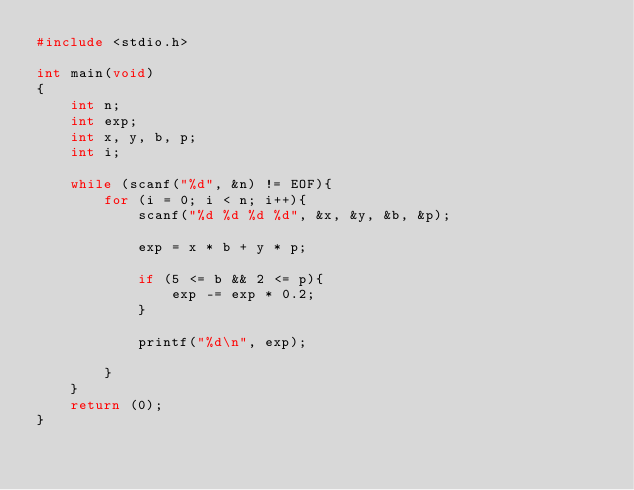<code> <loc_0><loc_0><loc_500><loc_500><_C_>#include <stdio.h>

int main(void)
{
	int n;
	int exp;
	int x, y, b, p;
	int i;
	
	while (scanf("%d", &n) != EOF){
		for (i = 0; i < n; i++){
			scanf("%d %d %d %d", &x, &y, &b, &p);
			
			exp = x * b + y * p;
			
			if (5 <= b && 2 <= p){
				exp -= exp * 0.2;
			}
			
			printf("%d\n", exp);
			
		}
	}
	return (0);
}</code> 